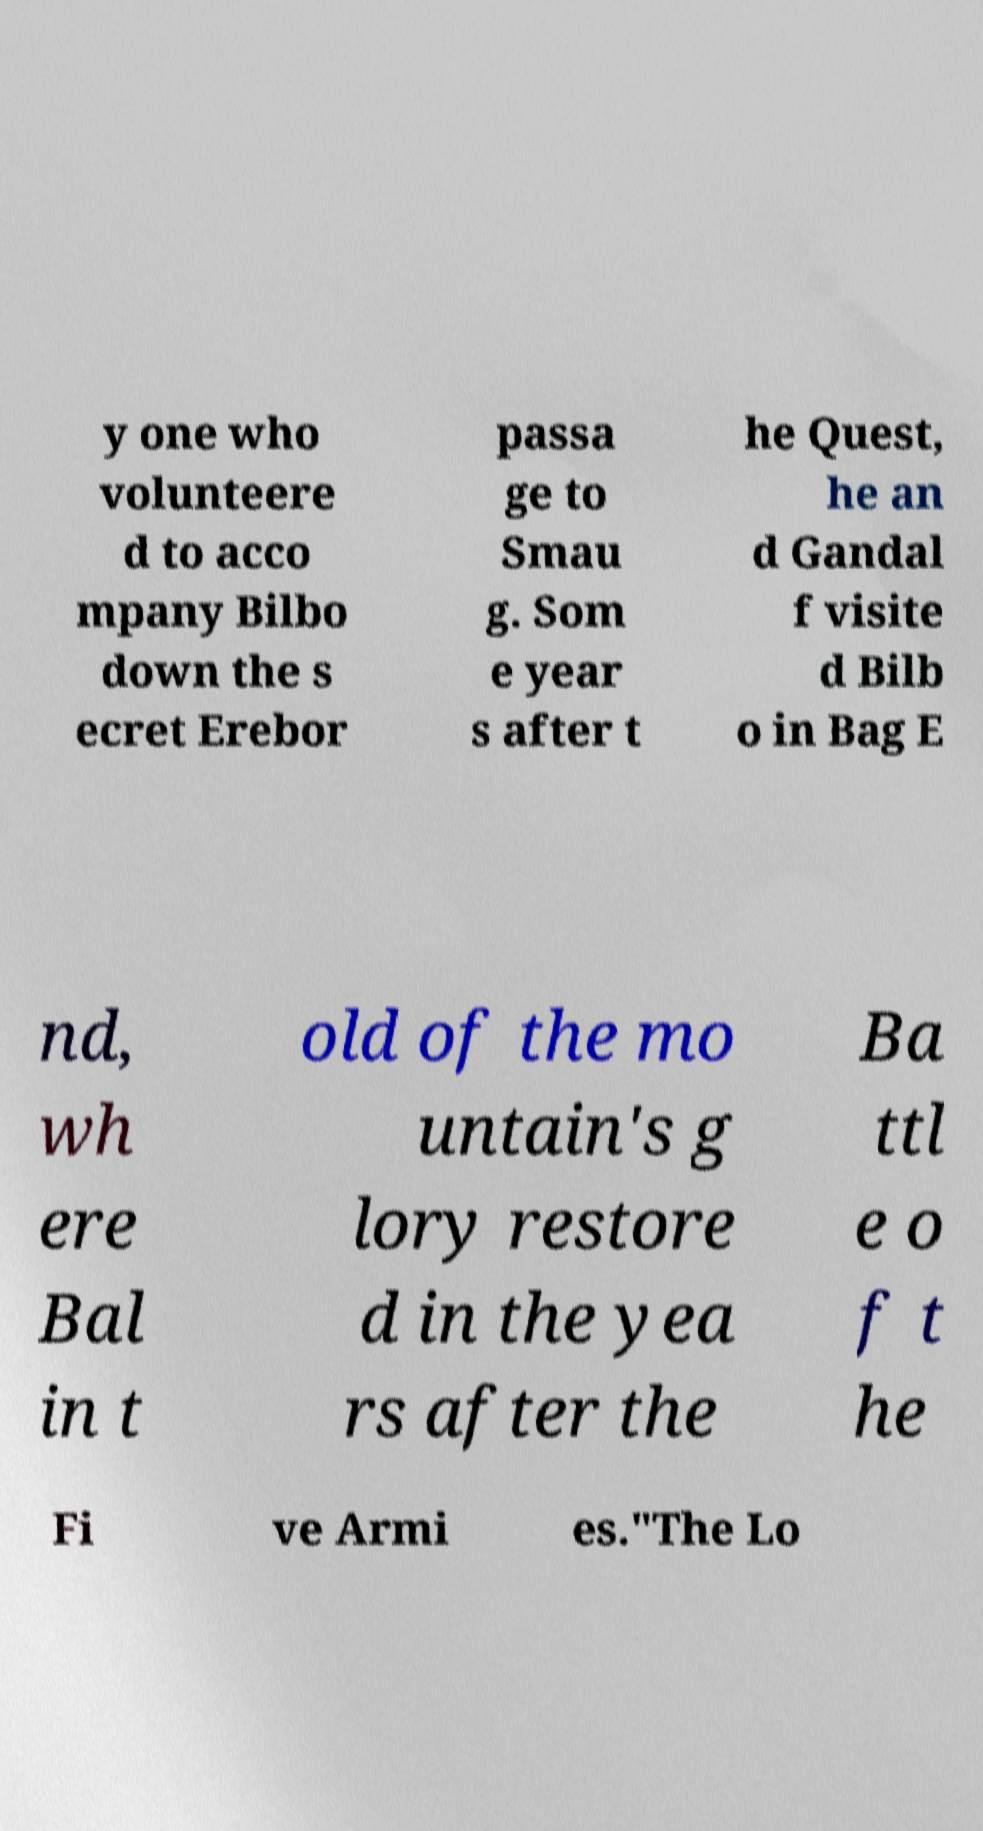Please read and relay the text visible in this image. What does it say? y one who volunteere d to acco mpany Bilbo down the s ecret Erebor passa ge to Smau g. Som e year s after t he Quest, he an d Gandal f visite d Bilb o in Bag E nd, wh ere Bal in t old of the mo untain's g lory restore d in the yea rs after the Ba ttl e o f t he Fi ve Armi es."The Lo 